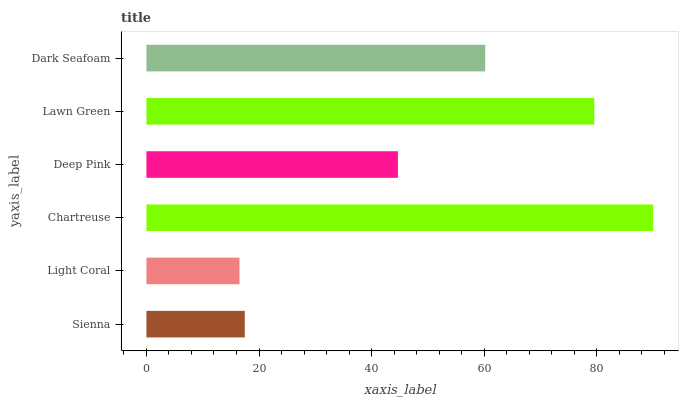Is Light Coral the minimum?
Answer yes or no. Yes. Is Chartreuse the maximum?
Answer yes or no. Yes. Is Chartreuse the minimum?
Answer yes or no. No. Is Light Coral the maximum?
Answer yes or no. No. Is Chartreuse greater than Light Coral?
Answer yes or no. Yes. Is Light Coral less than Chartreuse?
Answer yes or no. Yes. Is Light Coral greater than Chartreuse?
Answer yes or no. No. Is Chartreuse less than Light Coral?
Answer yes or no. No. Is Dark Seafoam the high median?
Answer yes or no. Yes. Is Deep Pink the low median?
Answer yes or no. Yes. Is Lawn Green the high median?
Answer yes or no. No. Is Lawn Green the low median?
Answer yes or no. No. 